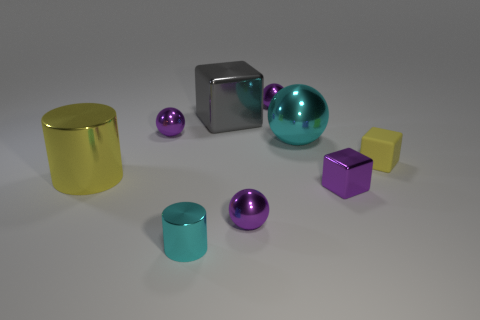How do the shadows cast by the objects vary? The shadows cast by these objects vary in both length and sharpness, which suggests differences in their heights and the angles they present to the light source. Taller objects and those placed at a steeper angle to the light tend to have longer, more distinct shadows. 